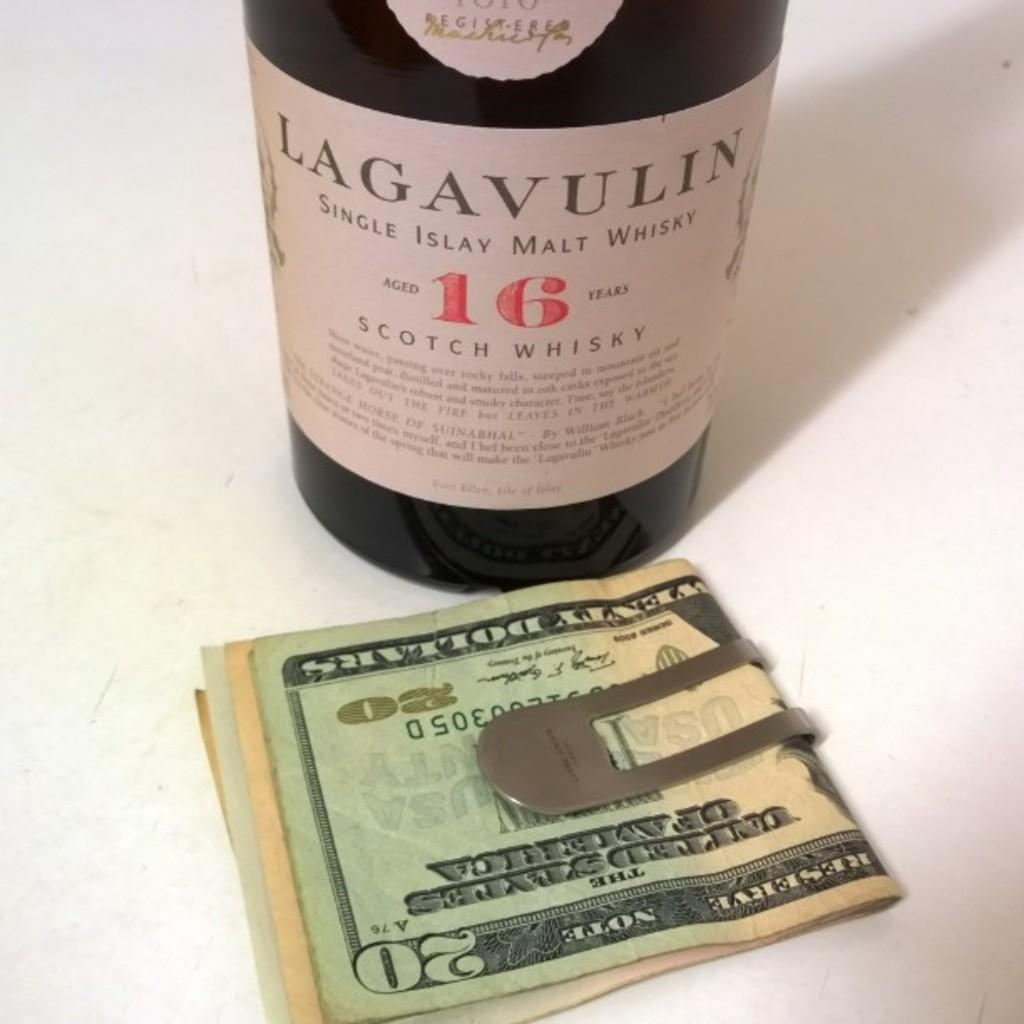Provide a one-sentence caption for the provided image. bottle of lagavulin scotch whisky and moneyclip holding several bills including a $20 bill. 